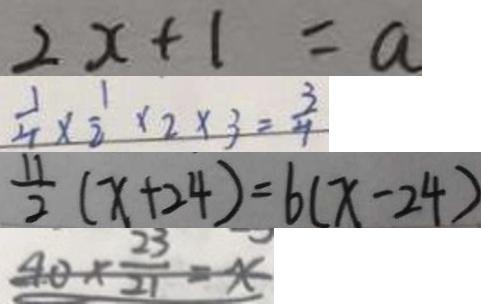Convert formula to latex. <formula><loc_0><loc_0><loc_500><loc_500>2 x + 1 = a 
 \frac { 1 } { 4 } \times \frac { 1 } { 2 } \times 2 \times 3 = \frac { 3 } { 4 } 
 \frac { 1 1 } { 2 } ( x + 2 4 ) = 6 ( x - 2 4 ) 
 4 0 \times \frac { 2 3 } { 2 1 } = x</formula> 